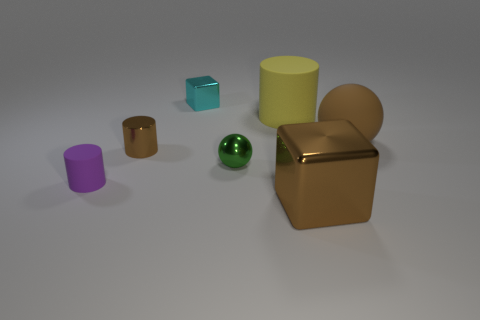Is there anything else that is the same size as the green metallic thing? Yes, the purple cylinder appears to be approximately the same height as the green metallic sphere, suggesting they could be of similar size. 